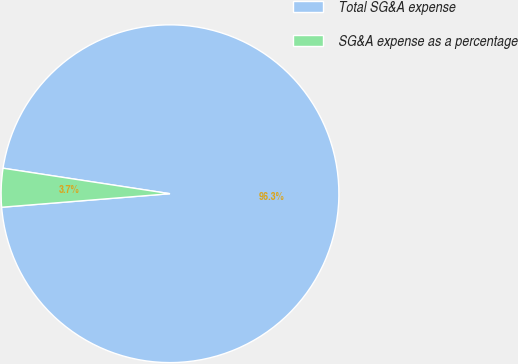<chart> <loc_0><loc_0><loc_500><loc_500><pie_chart><fcel>Total SG&A expense<fcel>SG&A expense as a percentage<nl><fcel>96.31%<fcel>3.69%<nl></chart> 